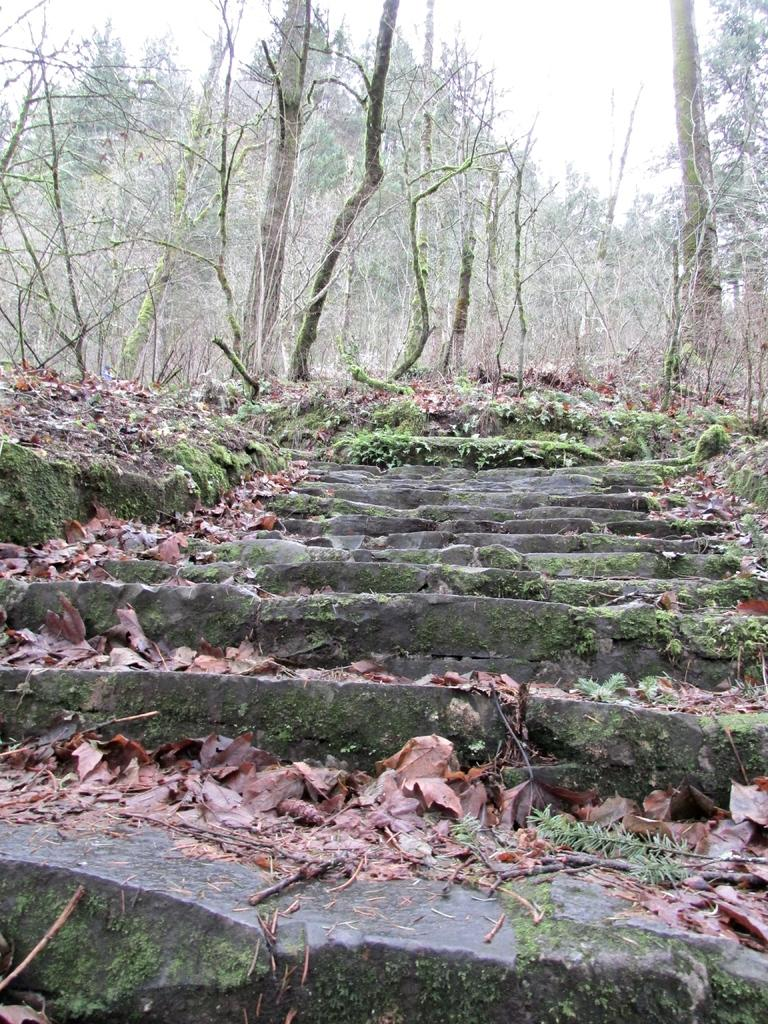What type of structure can be seen in the image? There are stairs in the image. What is on the ground near the stairs? Dry leaves are present on the ground. What type of vegetation is visible in the image? There are trees in the image. What can be seen in the background of the image? The sky is visible in the background of the image. Where is the maid standing with the crate of tin cans in the image? There is no maid, crate, or tin cans present in the image. 